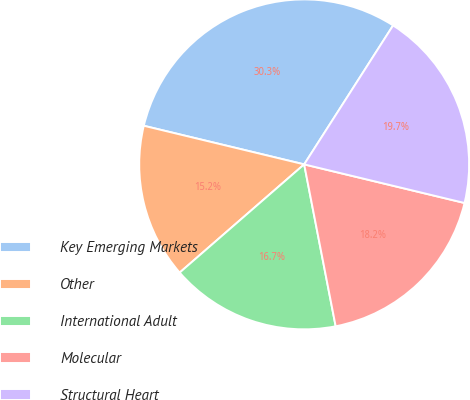Convert chart to OTSL. <chart><loc_0><loc_0><loc_500><loc_500><pie_chart><fcel>Key Emerging Markets<fcel>Other<fcel>International Adult<fcel>Molecular<fcel>Structural Heart<nl><fcel>30.3%<fcel>15.15%<fcel>16.67%<fcel>18.18%<fcel>19.7%<nl></chart> 